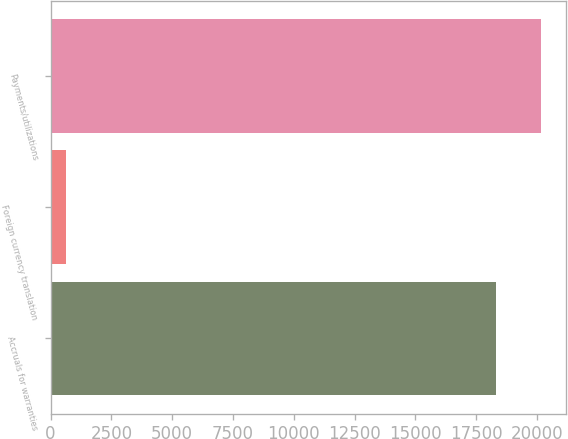Convert chart to OTSL. <chart><loc_0><loc_0><loc_500><loc_500><bar_chart><fcel>Accruals for warranties<fcel>Foreign currency translation<fcel>Payments/utilizations<nl><fcel>18327<fcel>641<fcel>20172.4<nl></chart> 